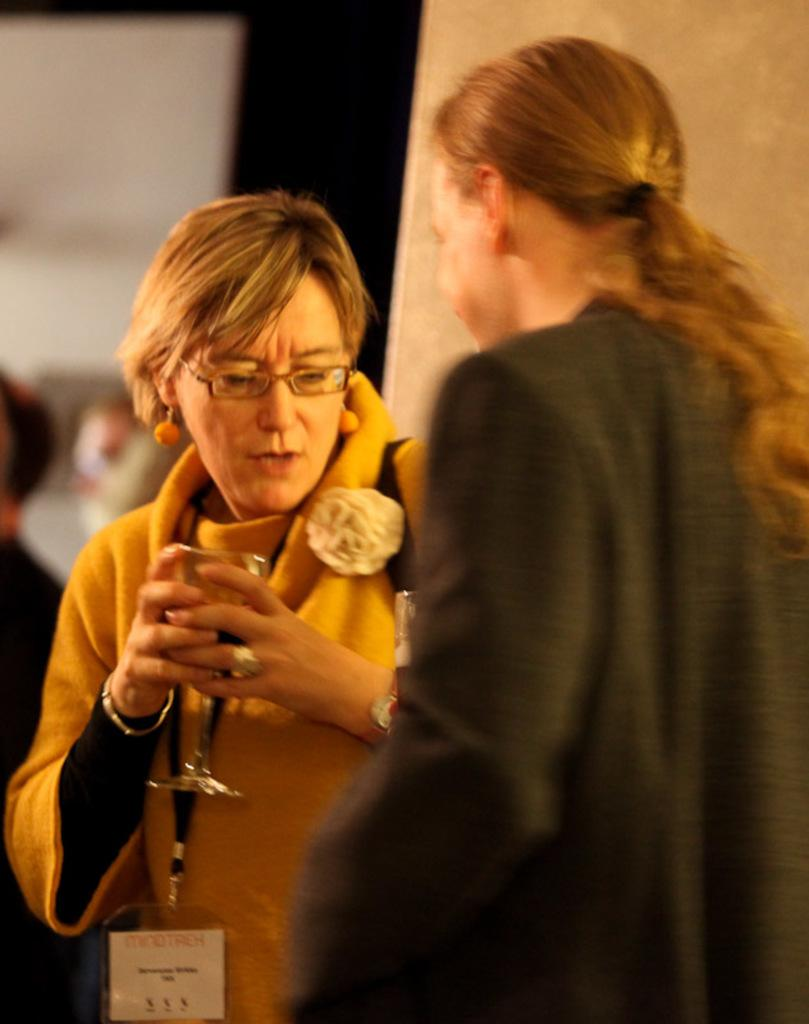How many people are present in the image? There are two people standing in the image. Can you describe one of the individuals in the image? There is a woman in the image. What is the woman holding in her hand? The woman is holding a glass in her hand. What type of drum can be heard playing in the background of the image? There is no drum or sound present in the image, as it is a still photograph. 